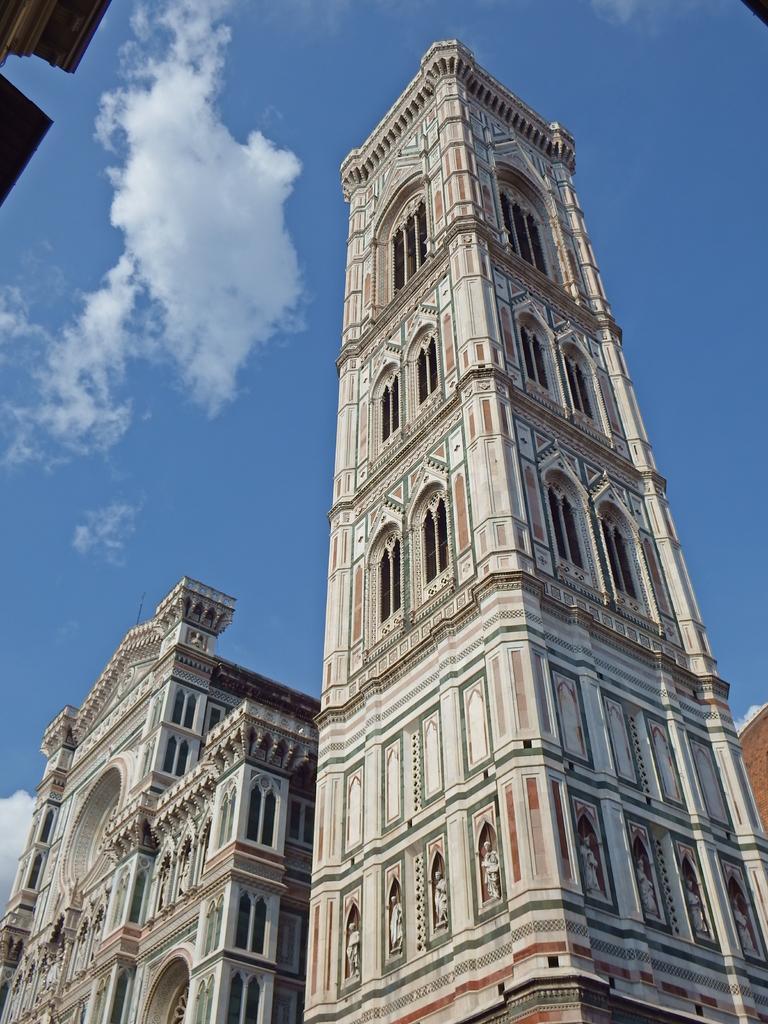Describe this image in one or two sentences. This is an outside view. At the bottom, I can see few buildings along with the windows. At the top of the image I can see the sky and clouds. 